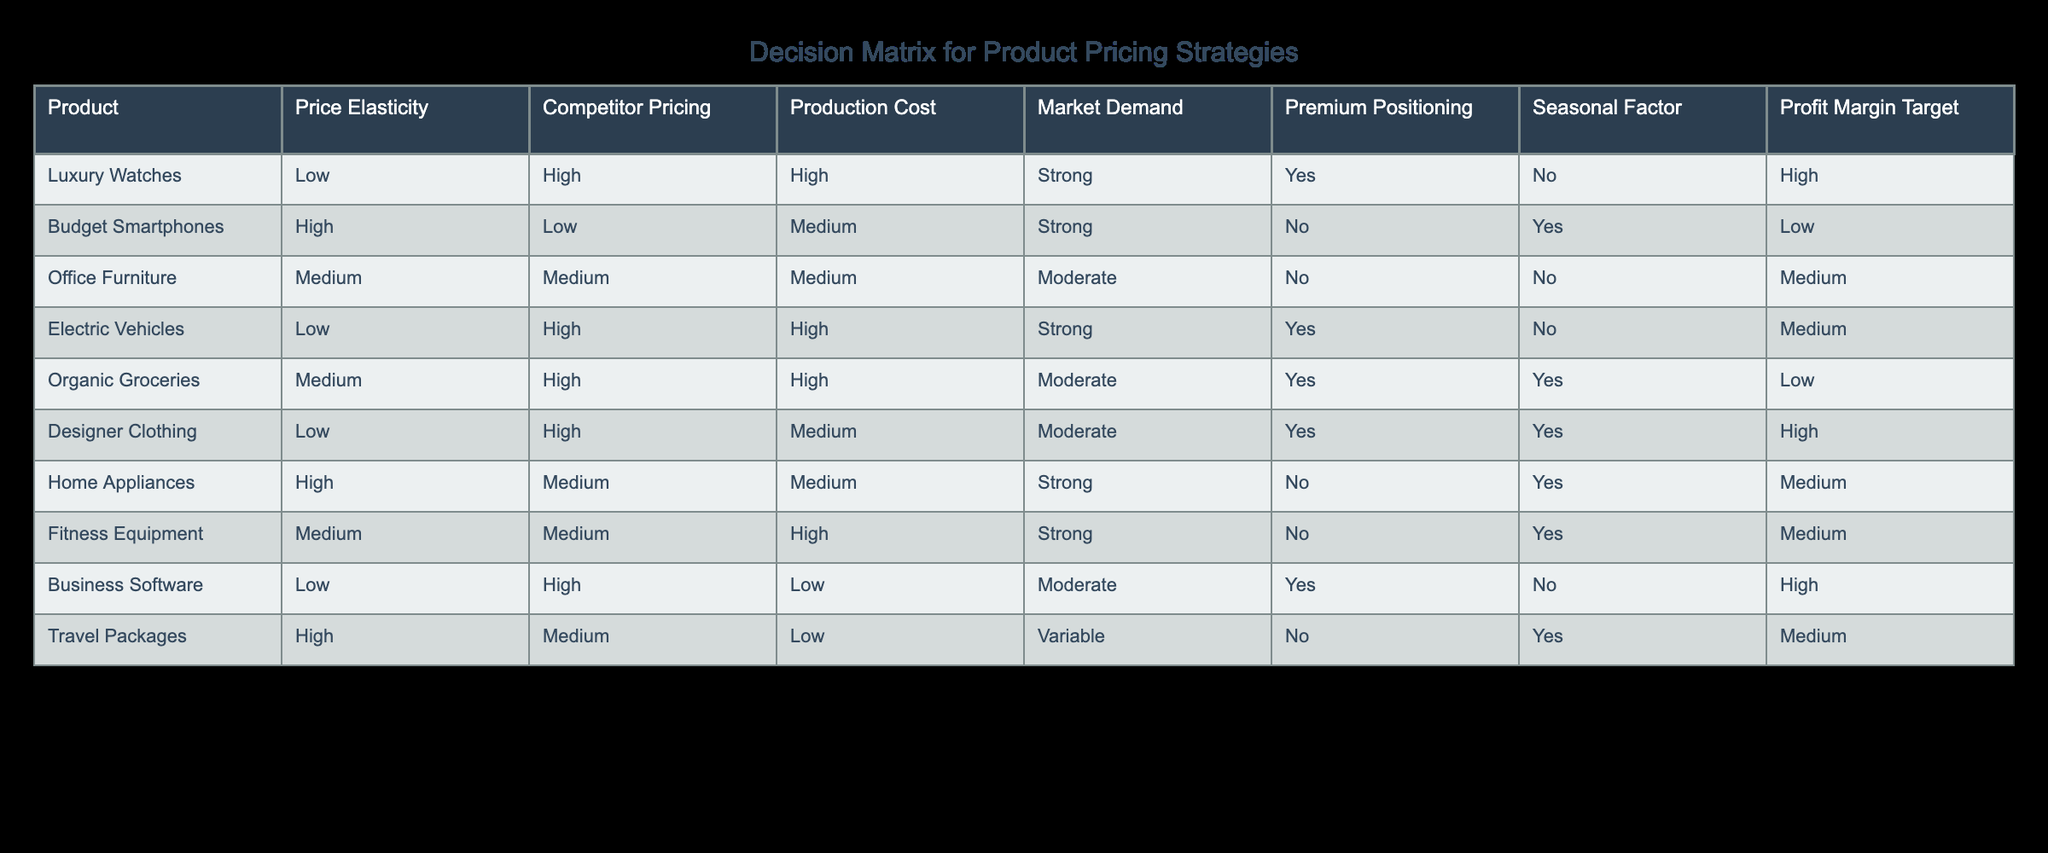What is the pricing strategy for Luxury Watches? The pricing strategy for Luxury Watches is set at a high price point despite having low price elasticity, high production costs, and strong market demand. Premium positioning is also identified, suggesting a focus on exclusivity and brand value.
Answer: High Which product has the highest target profit margin? Based on the table, Luxury Watches and Designer Clothing both have a high target profit margin. Evaluating the entries shows that both are set with premium positioning, implying they are targeted at a higher-end market.
Answer: Luxury Watches and Designer Clothing Is there any product with high price elasticity and a target profit margin of low? The Budget Smartphones exhibit high price elasticity and have a low target profit margin according to the table. This means they are sensitive to price changes which can affect sales significantly.
Answer: Yes What is the average production cost of the products listed? The production costs categorized by the table are High, Medium, Medium, High, High, Medium, Medium, High, Low, and Low. Adding these costs (High = 3, Medium = 4, Low = 2) leads to a total of 9 cost brackets. The average value can be derived by (3 * 3 + 4 * 2 + 2 * 1)/10 which simplifies down to medium production costs being predominant.
Answer: Medium What is the market demand for Organic Groceries? Reviewing the table, Organic Groceries has a moderate market demand; however, its pricing strategy focuses on premium positioning and is sensitive to seasonal factors. Market demand influences the sales strategy significantly.
Answer: Moderate Is there a product with both premium positioning and seasonal factors? The products that have premium positioning listed in the table are Luxury Watches, Designer Clothing, and Business Software. Both Luxury Watches and Designer Clothing do not have seasonal factors, while Business Software also doesn't fit this category. Thus, no products meet both criteria.
Answer: No For which product is the competitor pricing low? The product with low competitor pricing according to the table is Budget Smartphones. This means that there is an opportunity to price aggressively or position competitively in the market segment.
Answer: Budget Smartphones Which products are impacted by a seasonal factor? Looking at the table, the Budget Smartphones and Home Appliances are affected by the seasonal factor. Other products, such as Luxury Watches and Electric Vehicles, do not fall under this category.
Answer: Budget Smartphones and Home Appliances 